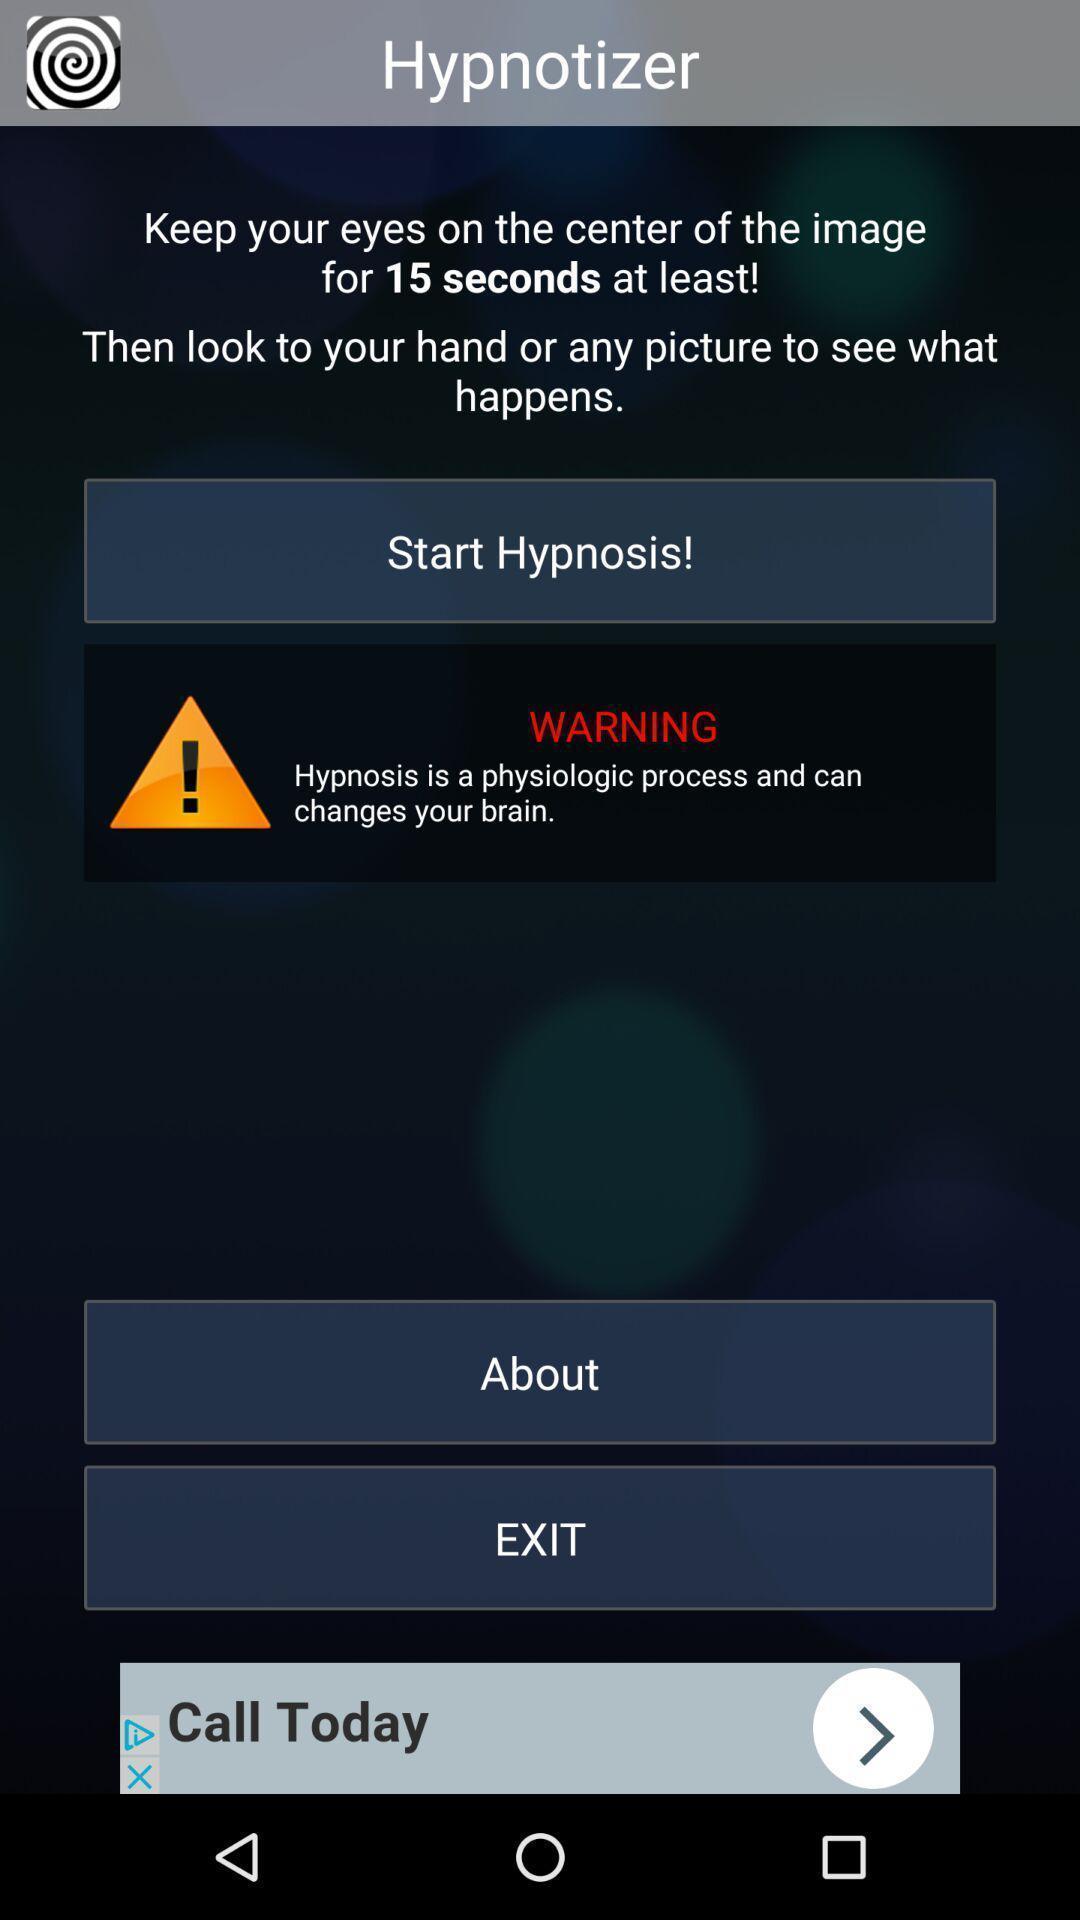Provide a detailed account of this screenshot. Start page. 